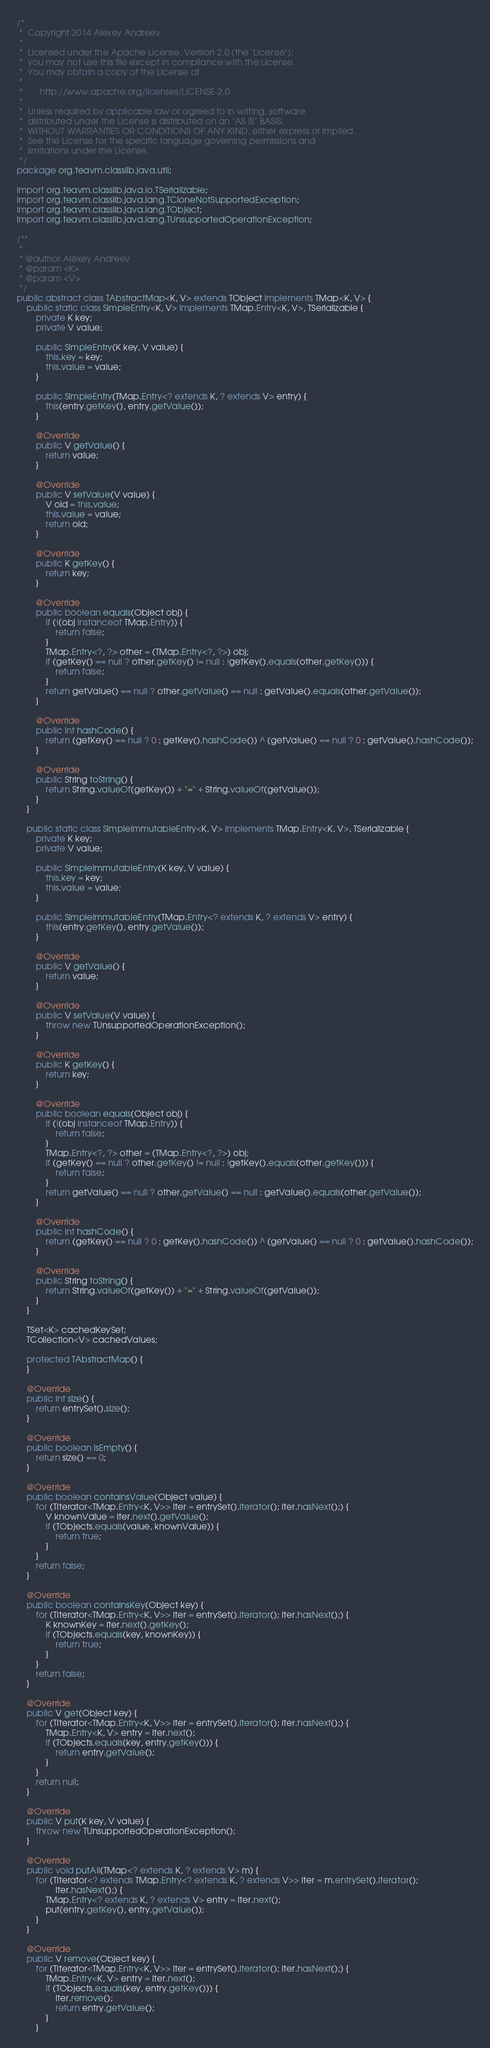Convert code to text. <code><loc_0><loc_0><loc_500><loc_500><_Java_>/*
 *  Copyright 2014 Alexey Andreev.
 *
 *  Licensed under the Apache License, Version 2.0 (the "License");
 *  you may not use this file except in compliance with the License.
 *  You may obtain a copy of the License at
 *
 *       http://www.apache.org/licenses/LICENSE-2.0
 *
 *  Unless required by applicable law or agreed to in writing, software
 *  distributed under the License is distributed on an "AS IS" BASIS,
 *  WITHOUT WARRANTIES OR CONDITIONS OF ANY KIND, either express or implied.
 *  See the License for the specific language governing permissions and
 *  limitations under the License.
 */
package org.teavm.classlib.java.util;

import org.teavm.classlib.java.io.TSerializable;
import org.teavm.classlib.java.lang.TCloneNotSupportedException;
import org.teavm.classlib.java.lang.TObject;
import org.teavm.classlib.java.lang.TUnsupportedOperationException;

/**
 *
 * @author Alexey Andreev
 * @param <K>
 * @param <V>
 */
public abstract class TAbstractMap<K, V> extends TObject implements TMap<K, V> {
    public static class SimpleEntry<K, V> implements TMap.Entry<K, V>, TSerializable {
        private K key;
        private V value;

        public SimpleEntry(K key, V value) {
            this.key = key;
            this.value = value;
        }

        public SimpleEntry(TMap.Entry<? extends K, ? extends V> entry) {
            this(entry.getKey(), entry.getValue());
        }

        @Override
        public V getValue() {
            return value;
        }

        @Override
        public V setValue(V value) {
            V old = this.value;
            this.value = value;
            return old;
        }

        @Override
        public K getKey() {
            return key;
        }

        @Override
        public boolean equals(Object obj) {
            if (!(obj instanceof TMap.Entry)) {
                return false;
            }
            TMap.Entry<?, ?> other = (TMap.Entry<?, ?>) obj;
            if (getKey() == null ? other.getKey() != null : !getKey().equals(other.getKey())) {
                return false;
            }
            return getValue() == null ? other.getValue() == null : getValue().equals(other.getValue());
        }

        @Override
        public int hashCode() {
            return (getKey() == null ? 0 : getKey().hashCode()) ^ (getValue() == null ? 0 : getValue().hashCode());
        }

        @Override
        public String toString() {
            return String.valueOf(getKey()) + "=" + String.valueOf(getValue());
        }
    }

    public static class SimpleImmutableEntry<K, V> implements TMap.Entry<K, V>, TSerializable {
        private K key;
        private V value;

        public SimpleImmutableEntry(K key, V value) {
            this.key = key;
            this.value = value;
        }

        public SimpleImmutableEntry(TMap.Entry<? extends K, ? extends V> entry) {
            this(entry.getKey(), entry.getValue());
        }

        @Override
        public V getValue() {
            return value;
        }

        @Override
        public V setValue(V value) {
            throw new TUnsupportedOperationException();
        }

        @Override
        public K getKey() {
            return key;
        }

        @Override
        public boolean equals(Object obj) {
            if (!(obj instanceof TMap.Entry)) {
                return false;
            }
            TMap.Entry<?, ?> other = (TMap.Entry<?, ?>) obj;
            if (getKey() == null ? other.getKey() != null : !getKey().equals(other.getKey())) {
                return false;
            }
            return getValue() == null ? other.getValue() == null : getValue().equals(other.getValue());
        }

        @Override
        public int hashCode() {
            return (getKey() == null ? 0 : getKey().hashCode()) ^ (getValue() == null ? 0 : getValue().hashCode());
        }

        @Override
        public String toString() {
            return String.valueOf(getKey()) + "=" + String.valueOf(getValue());
        }
    }

    TSet<K> cachedKeySet;
    TCollection<V> cachedValues;

    protected TAbstractMap() {
    }

    @Override
    public int size() {
        return entrySet().size();
    }

    @Override
    public boolean isEmpty() {
        return size() == 0;
    }

    @Override
    public boolean containsValue(Object value) {
        for (TIterator<TMap.Entry<K, V>> iter = entrySet().iterator(); iter.hasNext();) {
            V knownValue = iter.next().getValue();
            if (TObjects.equals(value, knownValue)) {
                return true;
            }
        }
        return false;
    }

    @Override
    public boolean containsKey(Object key) {
        for (TIterator<TMap.Entry<K, V>> iter = entrySet().iterator(); iter.hasNext();) {
            K knownKey = iter.next().getKey();
            if (TObjects.equals(key, knownKey)) {
                return true;
            }
        }
        return false;
    }

    @Override
    public V get(Object key) {
        for (TIterator<TMap.Entry<K, V>> iter = entrySet().iterator(); iter.hasNext();) {
            TMap.Entry<K, V> entry = iter.next();
            if (TObjects.equals(key, entry.getKey())) {
                return entry.getValue();
            }
        }
        return null;
    }

    @Override
    public V put(K key, V value) {
        throw new TUnsupportedOperationException();
    }

    @Override
    public void putAll(TMap<? extends K, ? extends V> m) {
        for (TIterator<? extends TMap.Entry<? extends K, ? extends V>> iter = m.entrySet().iterator();
                iter.hasNext();) {
            TMap.Entry<? extends K, ? extends V> entry = iter.next();
            put(entry.getKey(), entry.getValue());
        }
    }

    @Override
    public V remove(Object key) {
        for (TIterator<TMap.Entry<K, V>> iter = entrySet().iterator(); iter.hasNext();) {
            TMap.Entry<K, V> entry = iter.next();
            if (TObjects.equals(key, entry.getKey())) {
                iter.remove();
                return entry.getValue();
            }
        }</code> 